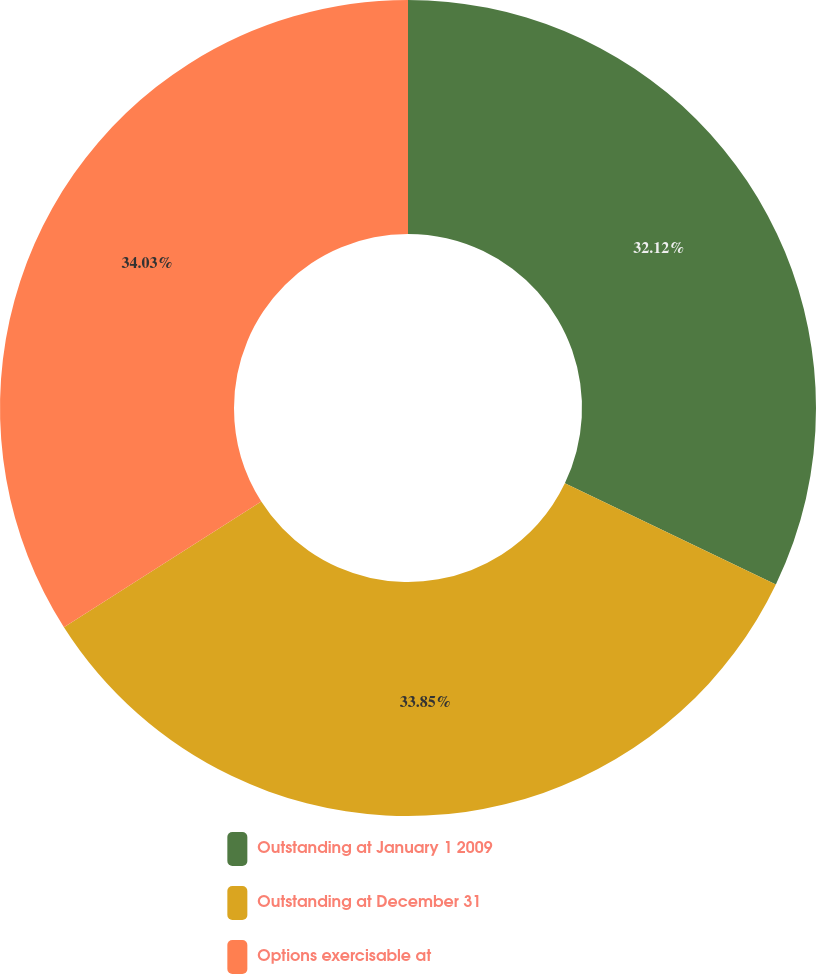Convert chart. <chart><loc_0><loc_0><loc_500><loc_500><pie_chart><fcel>Outstanding at January 1 2009<fcel>Outstanding at December 31<fcel>Options exercisable at<nl><fcel>32.12%<fcel>33.85%<fcel>34.03%<nl></chart> 